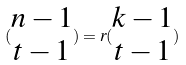Convert formula to latex. <formula><loc_0><loc_0><loc_500><loc_500>( \begin{matrix} n - 1 \\ t - 1 \end{matrix} ) = r ( \begin{matrix} k - 1 \\ t - 1 \end{matrix} )</formula> 